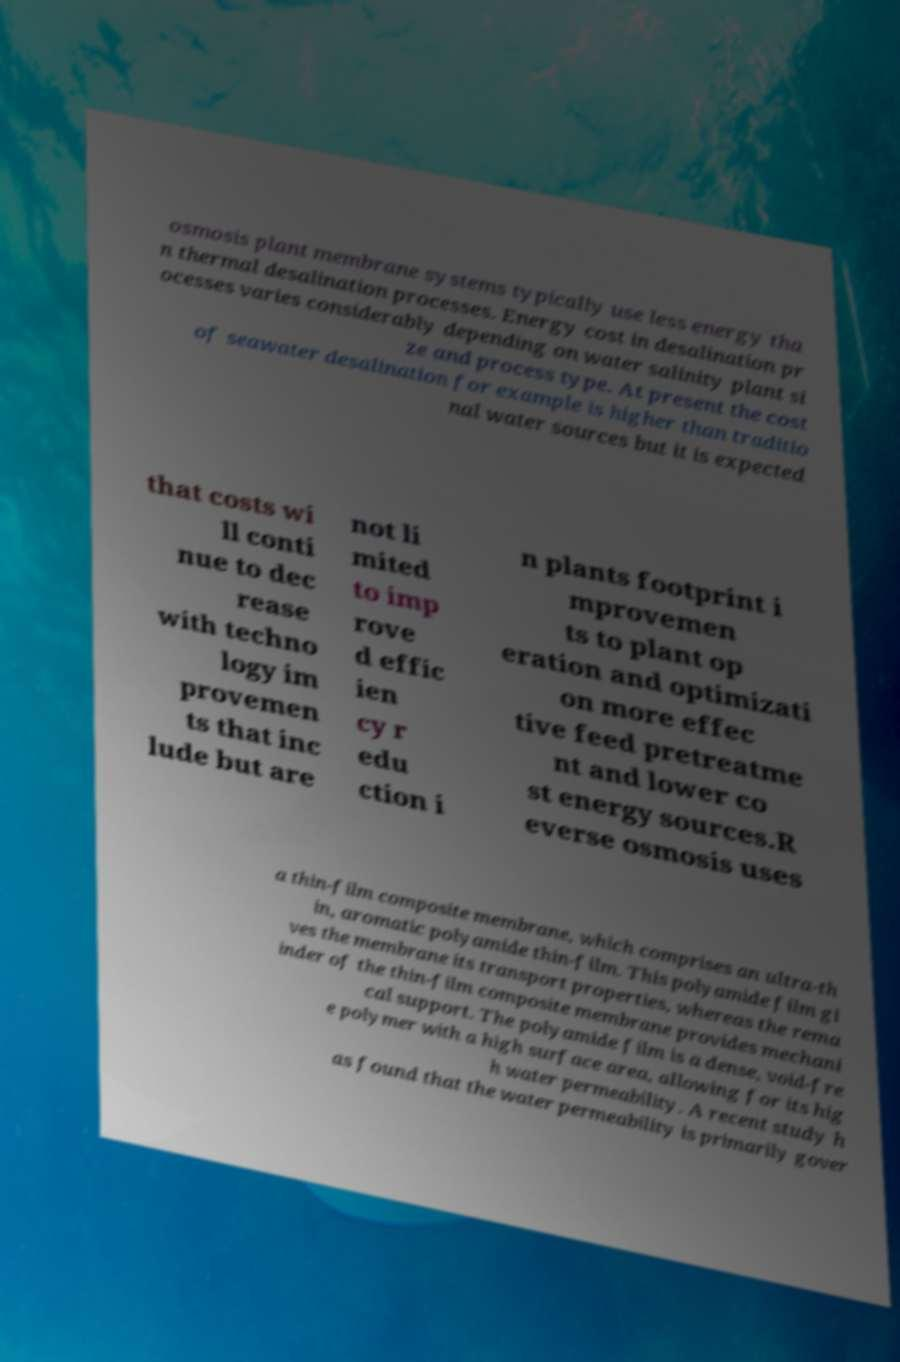Please identify and transcribe the text found in this image. osmosis plant membrane systems typically use less energy tha n thermal desalination processes. Energy cost in desalination pr ocesses varies considerably depending on water salinity plant si ze and process type. At present the cost of seawater desalination for example is higher than traditio nal water sources but it is expected that costs wi ll conti nue to dec rease with techno logy im provemen ts that inc lude but are not li mited to imp rove d effic ien cy r edu ction i n plants footprint i mprovemen ts to plant op eration and optimizati on more effec tive feed pretreatme nt and lower co st energy sources.R everse osmosis uses a thin-film composite membrane, which comprises an ultra-th in, aromatic polyamide thin-film. This polyamide film gi ves the membrane its transport properties, whereas the rema inder of the thin-film composite membrane provides mechani cal support. The polyamide film is a dense, void-fre e polymer with a high surface area, allowing for its hig h water permeability. A recent study h as found that the water permeability is primarily gover 